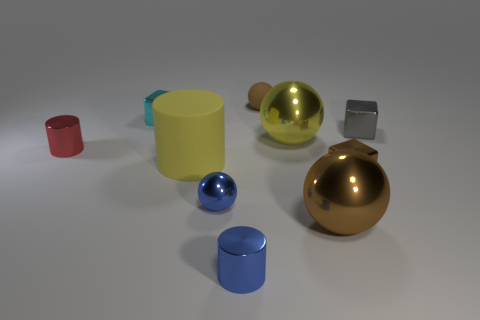Subtract all spheres. How many objects are left? 6 Add 7 blue balls. How many blue balls are left? 8 Add 8 tiny brown shiny blocks. How many tiny brown shiny blocks exist? 9 Subtract 1 red cylinders. How many objects are left? 9 Subtract all blue metallic things. Subtract all small red metallic blocks. How many objects are left? 8 